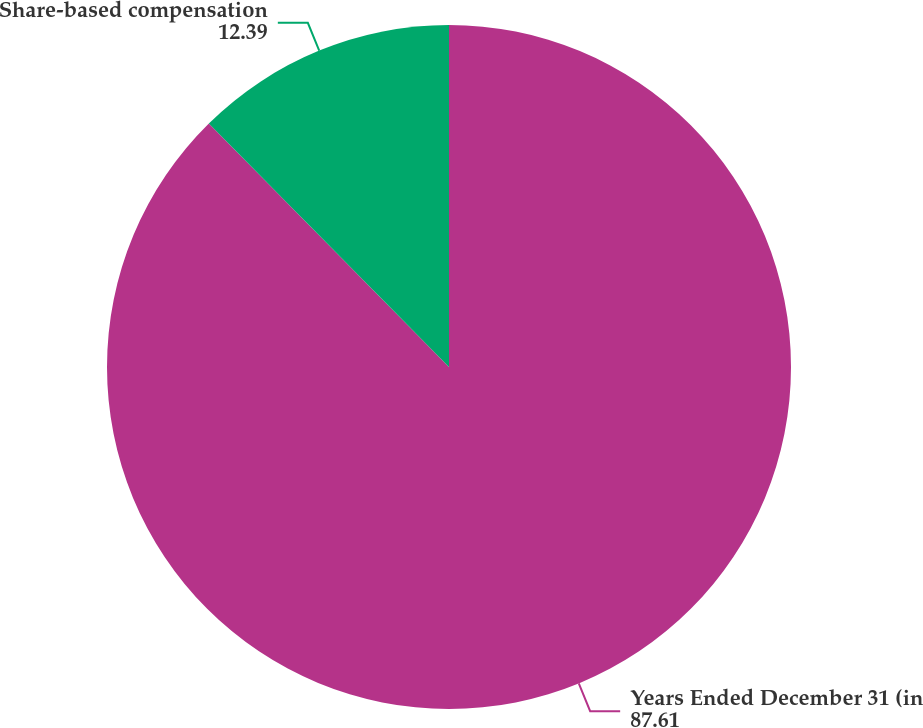Convert chart. <chart><loc_0><loc_0><loc_500><loc_500><pie_chart><fcel>Years Ended December 31 (in<fcel>Share-based compensation<nl><fcel>87.61%<fcel>12.39%<nl></chart> 